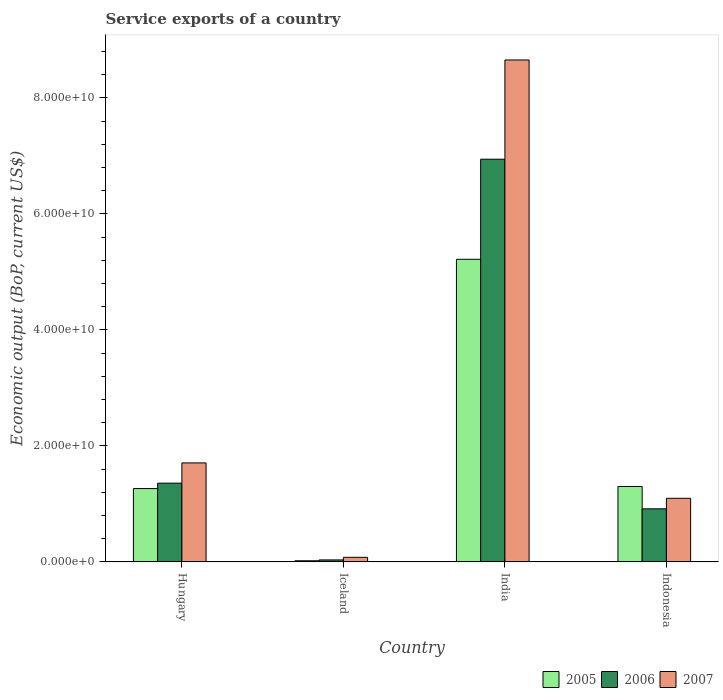Are the number of bars per tick equal to the number of legend labels?
Keep it short and to the point. Yes. How many bars are there on the 1st tick from the left?
Ensure brevity in your answer.  3. How many bars are there on the 2nd tick from the right?
Your answer should be compact. 3. What is the label of the 2nd group of bars from the left?
Keep it short and to the point. Iceland. What is the service exports in 2007 in Iceland?
Keep it short and to the point. 7.86e+08. Across all countries, what is the maximum service exports in 2007?
Keep it short and to the point. 8.66e+1. Across all countries, what is the minimum service exports in 2006?
Offer a very short reply. 3.39e+08. In which country was the service exports in 2006 maximum?
Provide a succinct answer. India. What is the total service exports in 2005 in the graph?
Keep it short and to the point. 7.80e+1. What is the difference between the service exports in 2005 in Iceland and that in India?
Offer a terse response. -5.20e+1. What is the difference between the service exports in 2007 in India and the service exports in 2005 in Iceland?
Give a very brief answer. 8.64e+1. What is the average service exports in 2006 per country?
Make the answer very short. 2.31e+1. What is the difference between the service exports of/in 2007 and service exports of/in 2005 in Hungary?
Give a very brief answer. 4.42e+09. What is the ratio of the service exports in 2006 in Iceland to that in India?
Your answer should be compact. 0. Is the difference between the service exports in 2007 in Iceland and Indonesia greater than the difference between the service exports in 2005 in Iceland and Indonesia?
Give a very brief answer. Yes. What is the difference between the highest and the second highest service exports in 2006?
Provide a succinct answer. -6.03e+1. What is the difference between the highest and the lowest service exports in 2005?
Make the answer very short. 5.20e+1. Is the sum of the service exports in 2006 in Hungary and Indonesia greater than the maximum service exports in 2005 across all countries?
Ensure brevity in your answer.  No. What does the 2nd bar from the left in Hungary represents?
Your response must be concise. 2006. What does the 1st bar from the right in Iceland represents?
Make the answer very short. 2007. Is it the case that in every country, the sum of the service exports in 2006 and service exports in 2005 is greater than the service exports in 2007?
Provide a succinct answer. No. How many bars are there?
Provide a succinct answer. 12. Are all the bars in the graph horizontal?
Your response must be concise. No. Are the values on the major ticks of Y-axis written in scientific E-notation?
Offer a very short reply. Yes. Does the graph contain any zero values?
Offer a terse response. No. Where does the legend appear in the graph?
Offer a terse response. Bottom right. How are the legend labels stacked?
Provide a short and direct response. Horizontal. What is the title of the graph?
Make the answer very short. Service exports of a country. Does "1960" appear as one of the legend labels in the graph?
Make the answer very short. No. What is the label or title of the X-axis?
Provide a succinct answer. Country. What is the label or title of the Y-axis?
Provide a succinct answer. Economic output (BoP, current US$). What is the Economic output (BoP, current US$) of 2005 in Hungary?
Give a very brief answer. 1.26e+1. What is the Economic output (BoP, current US$) in 2006 in Hungary?
Your answer should be compact. 1.36e+1. What is the Economic output (BoP, current US$) of 2007 in Hungary?
Offer a very short reply. 1.71e+1. What is the Economic output (BoP, current US$) of 2005 in Iceland?
Offer a very short reply. 1.92e+08. What is the Economic output (BoP, current US$) in 2006 in Iceland?
Your answer should be very brief. 3.39e+08. What is the Economic output (BoP, current US$) in 2007 in Iceland?
Offer a very short reply. 7.86e+08. What is the Economic output (BoP, current US$) in 2005 in India?
Offer a terse response. 5.22e+1. What is the Economic output (BoP, current US$) in 2006 in India?
Offer a very short reply. 6.94e+1. What is the Economic output (BoP, current US$) in 2007 in India?
Offer a very short reply. 8.66e+1. What is the Economic output (BoP, current US$) in 2005 in Indonesia?
Provide a short and direct response. 1.30e+1. What is the Economic output (BoP, current US$) of 2006 in Indonesia?
Provide a succinct answer. 9.15e+09. What is the Economic output (BoP, current US$) in 2007 in Indonesia?
Your response must be concise. 1.10e+1. Across all countries, what is the maximum Economic output (BoP, current US$) in 2005?
Provide a succinct answer. 5.22e+1. Across all countries, what is the maximum Economic output (BoP, current US$) in 2006?
Keep it short and to the point. 6.94e+1. Across all countries, what is the maximum Economic output (BoP, current US$) in 2007?
Keep it short and to the point. 8.66e+1. Across all countries, what is the minimum Economic output (BoP, current US$) of 2005?
Offer a terse response. 1.92e+08. Across all countries, what is the minimum Economic output (BoP, current US$) of 2006?
Give a very brief answer. 3.39e+08. Across all countries, what is the minimum Economic output (BoP, current US$) of 2007?
Your answer should be very brief. 7.86e+08. What is the total Economic output (BoP, current US$) of 2005 in the graph?
Provide a short and direct response. 7.80e+1. What is the total Economic output (BoP, current US$) of 2006 in the graph?
Give a very brief answer. 9.25e+1. What is the total Economic output (BoP, current US$) in 2007 in the graph?
Offer a terse response. 1.15e+11. What is the difference between the Economic output (BoP, current US$) of 2005 in Hungary and that in Iceland?
Keep it short and to the point. 1.25e+1. What is the difference between the Economic output (BoP, current US$) in 2006 in Hungary and that in Iceland?
Provide a short and direct response. 1.32e+1. What is the difference between the Economic output (BoP, current US$) in 2007 in Hungary and that in Iceland?
Offer a terse response. 1.63e+1. What is the difference between the Economic output (BoP, current US$) in 2005 in Hungary and that in India?
Your answer should be compact. -3.95e+1. What is the difference between the Economic output (BoP, current US$) of 2006 in Hungary and that in India?
Your response must be concise. -5.59e+1. What is the difference between the Economic output (BoP, current US$) in 2007 in Hungary and that in India?
Keep it short and to the point. -6.95e+1. What is the difference between the Economic output (BoP, current US$) in 2005 in Hungary and that in Indonesia?
Provide a short and direct response. -3.55e+08. What is the difference between the Economic output (BoP, current US$) of 2006 in Hungary and that in Indonesia?
Your answer should be very brief. 4.43e+09. What is the difference between the Economic output (BoP, current US$) in 2007 in Hungary and that in Indonesia?
Your answer should be compact. 6.10e+09. What is the difference between the Economic output (BoP, current US$) of 2005 in Iceland and that in India?
Your response must be concise. -5.20e+1. What is the difference between the Economic output (BoP, current US$) of 2006 in Iceland and that in India?
Make the answer very short. -6.91e+1. What is the difference between the Economic output (BoP, current US$) in 2007 in Iceland and that in India?
Your answer should be very brief. -8.58e+1. What is the difference between the Economic output (BoP, current US$) in 2005 in Iceland and that in Indonesia?
Offer a very short reply. -1.28e+1. What is the difference between the Economic output (BoP, current US$) of 2006 in Iceland and that in Indonesia?
Your response must be concise. -8.81e+09. What is the difference between the Economic output (BoP, current US$) of 2007 in Iceland and that in Indonesia?
Ensure brevity in your answer.  -1.02e+1. What is the difference between the Economic output (BoP, current US$) in 2005 in India and that in Indonesia?
Make the answer very short. 3.92e+1. What is the difference between the Economic output (BoP, current US$) of 2006 in India and that in Indonesia?
Make the answer very short. 6.03e+1. What is the difference between the Economic output (BoP, current US$) in 2007 in India and that in Indonesia?
Your answer should be very brief. 7.56e+1. What is the difference between the Economic output (BoP, current US$) in 2005 in Hungary and the Economic output (BoP, current US$) in 2006 in Iceland?
Give a very brief answer. 1.23e+1. What is the difference between the Economic output (BoP, current US$) in 2005 in Hungary and the Economic output (BoP, current US$) in 2007 in Iceland?
Make the answer very short. 1.19e+1. What is the difference between the Economic output (BoP, current US$) of 2006 in Hungary and the Economic output (BoP, current US$) of 2007 in Iceland?
Give a very brief answer. 1.28e+1. What is the difference between the Economic output (BoP, current US$) in 2005 in Hungary and the Economic output (BoP, current US$) in 2006 in India?
Give a very brief answer. -5.68e+1. What is the difference between the Economic output (BoP, current US$) of 2005 in Hungary and the Economic output (BoP, current US$) of 2007 in India?
Keep it short and to the point. -7.39e+1. What is the difference between the Economic output (BoP, current US$) of 2006 in Hungary and the Economic output (BoP, current US$) of 2007 in India?
Give a very brief answer. -7.30e+1. What is the difference between the Economic output (BoP, current US$) in 2005 in Hungary and the Economic output (BoP, current US$) in 2006 in Indonesia?
Give a very brief answer. 3.49e+09. What is the difference between the Economic output (BoP, current US$) of 2005 in Hungary and the Economic output (BoP, current US$) of 2007 in Indonesia?
Ensure brevity in your answer.  1.68e+09. What is the difference between the Economic output (BoP, current US$) of 2006 in Hungary and the Economic output (BoP, current US$) of 2007 in Indonesia?
Give a very brief answer. 2.61e+09. What is the difference between the Economic output (BoP, current US$) in 2005 in Iceland and the Economic output (BoP, current US$) in 2006 in India?
Your answer should be very brief. -6.92e+1. What is the difference between the Economic output (BoP, current US$) of 2005 in Iceland and the Economic output (BoP, current US$) of 2007 in India?
Keep it short and to the point. -8.64e+1. What is the difference between the Economic output (BoP, current US$) of 2006 in Iceland and the Economic output (BoP, current US$) of 2007 in India?
Provide a succinct answer. -8.62e+1. What is the difference between the Economic output (BoP, current US$) of 2005 in Iceland and the Economic output (BoP, current US$) of 2006 in Indonesia?
Your answer should be very brief. -8.96e+09. What is the difference between the Economic output (BoP, current US$) of 2005 in Iceland and the Economic output (BoP, current US$) of 2007 in Indonesia?
Provide a short and direct response. -1.08e+1. What is the difference between the Economic output (BoP, current US$) of 2006 in Iceland and the Economic output (BoP, current US$) of 2007 in Indonesia?
Keep it short and to the point. -1.06e+1. What is the difference between the Economic output (BoP, current US$) of 2005 in India and the Economic output (BoP, current US$) of 2006 in Indonesia?
Offer a very short reply. 4.30e+1. What is the difference between the Economic output (BoP, current US$) in 2005 in India and the Economic output (BoP, current US$) in 2007 in Indonesia?
Give a very brief answer. 4.12e+1. What is the difference between the Economic output (BoP, current US$) in 2006 in India and the Economic output (BoP, current US$) in 2007 in Indonesia?
Provide a short and direct response. 5.85e+1. What is the average Economic output (BoP, current US$) of 2005 per country?
Provide a succinct answer. 1.95e+1. What is the average Economic output (BoP, current US$) of 2006 per country?
Your response must be concise. 2.31e+1. What is the average Economic output (BoP, current US$) of 2007 per country?
Your response must be concise. 2.88e+1. What is the difference between the Economic output (BoP, current US$) of 2005 and Economic output (BoP, current US$) of 2006 in Hungary?
Provide a short and direct response. -9.35e+08. What is the difference between the Economic output (BoP, current US$) of 2005 and Economic output (BoP, current US$) of 2007 in Hungary?
Your response must be concise. -4.42e+09. What is the difference between the Economic output (BoP, current US$) of 2006 and Economic output (BoP, current US$) of 2007 in Hungary?
Provide a short and direct response. -3.49e+09. What is the difference between the Economic output (BoP, current US$) in 2005 and Economic output (BoP, current US$) in 2006 in Iceland?
Provide a succinct answer. -1.48e+08. What is the difference between the Economic output (BoP, current US$) of 2005 and Economic output (BoP, current US$) of 2007 in Iceland?
Your answer should be very brief. -5.95e+08. What is the difference between the Economic output (BoP, current US$) in 2006 and Economic output (BoP, current US$) in 2007 in Iceland?
Provide a short and direct response. -4.47e+08. What is the difference between the Economic output (BoP, current US$) in 2005 and Economic output (BoP, current US$) in 2006 in India?
Provide a short and direct response. -1.73e+1. What is the difference between the Economic output (BoP, current US$) of 2005 and Economic output (BoP, current US$) of 2007 in India?
Your answer should be very brief. -3.44e+1. What is the difference between the Economic output (BoP, current US$) of 2006 and Economic output (BoP, current US$) of 2007 in India?
Give a very brief answer. -1.71e+1. What is the difference between the Economic output (BoP, current US$) of 2005 and Economic output (BoP, current US$) of 2006 in Indonesia?
Provide a succinct answer. 3.85e+09. What is the difference between the Economic output (BoP, current US$) in 2005 and Economic output (BoP, current US$) in 2007 in Indonesia?
Keep it short and to the point. 2.03e+09. What is the difference between the Economic output (BoP, current US$) in 2006 and Economic output (BoP, current US$) in 2007 in Indonesia?
Ensure brevity in your answer.  -1.82e+09. What is the ratio of the Economic output (BoP, current US$) in 2005 in Hungary to that in Iceland?
Provide a short and direct response. 65.99. What is the ratio of the Economic output (BoP, current US$) of 2006 in Hungary to that in Iceland?
Provide a short and direct response. 40.03. What is the ratio of the Economic output (BoP, current US$) of 2007 in Hungary to that in Iceland?
Ensure brevity in your answer.  21.71. What is the ratio of the Economic output (BoP, current US$) in 2005 in Hungary to that in India?
Provide a succinct answer. 0.24. What is the ratio of the Economic output (BoP, current US$) of 2006 in Hungary to that in India?
Your answer should be very brief. 0.2. What is the ratio of the Economic output (BoP, current US$) in 2007 in Hungary to that in India?
Ensure brevity in your answer.  0.2. What is the ratio of the Economic output (BoP, current US$) in 2005 in Hungary to that in Indonesia?
Give a very brief answer. 0.97. What is the ratio of the Economic output (BoP, current US$) of 2006 in Hungary to that in Indonesia?
Offer a very short reply. 1.48. What is the ratio of the Economic output (BoP, current US$) of 2007 in Hungary to that in Indonesia?
Make the answer very short. 1.56. What is the ratio of the Economic output (BoP, current US$) of 2005 in Iceland to that in India?
Keep it short and to the point. 0. What is the ratio of the Economic output (BoP, current US$) of 2006 in Iceland to that in India?
Offer a terse response. 0. What is the ratio of the Economic output (BoP, current US$) of 2007 in Iceland to that in India?
Your response must be concise. 0.01. What is the ratio of the Economic output (BoP, current US$) of 2005 in Iceland to that in Indonesia?
Offer a very short reply. 0.01. What is the ratio of the Economic output (BoP, current US$) in 2006 in Iceland to that in Indonesia?
Give a very brief answer. 0.04. What is the ratio of the Economic output (BoP, current US$) in 2007 in Iceland to that in Indonesia?
Make the answer very short. 0.07. What is the ratio of the Economic output (BoP, current US$) in 2005 in India to that in Indonesia?
Provide a short and direct response. 4.01. What is the ratio of the Economic output (BoP, current US$) of 2006 in India to that in Indonesia?
Provide a short and direct response. 7.59. What is the ratio of the Economic output (BoP, current US$) of 2007 in India to that in Indonesia?
Provide a short and direct response. 7.89. What is the difference between the highest and the second highest Economic output (BoP, current US$) of 2005?
Provide a short and direct response. 3.92e+1. What is the difference between the highest and the second highest Economic output (BoP, current US$) of 2006?
Give a very brief answer. 5.59e+1. What is the difference between the highest and the second highest Economic output (BoP, current US$) of 2007?
Make the answer very short. 6.95e+1. What is the difference between the highest and the lowest Economic output (BoP, current US$) in 2005?
Your answer should be very brief. 5.20e+1. What is the difference between the highest and the lowest Economic output (BoP, current US$) of 2006?
Give a very brief answer. 6.91e+1. What is the difference between the highest and the lowest Economic output (BoP, current US$) of 2007?
Provide a succinct answer. 8.58e+1. 